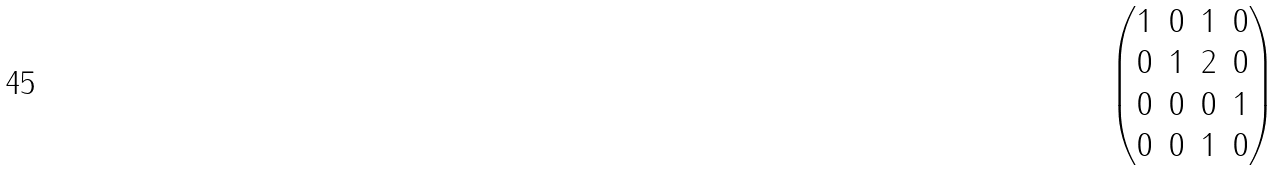<formula> <loc_0><loc_0><loc_500><loc_500>\begin{pmatrix} 1 & 0 & 1 & 0 \\ 0 & 1 & 2 & 0 \\ 0 & 0 & 0 & 1 \\ 0 & 0 & 1 & 0 \end{pmatrix}</formula> 